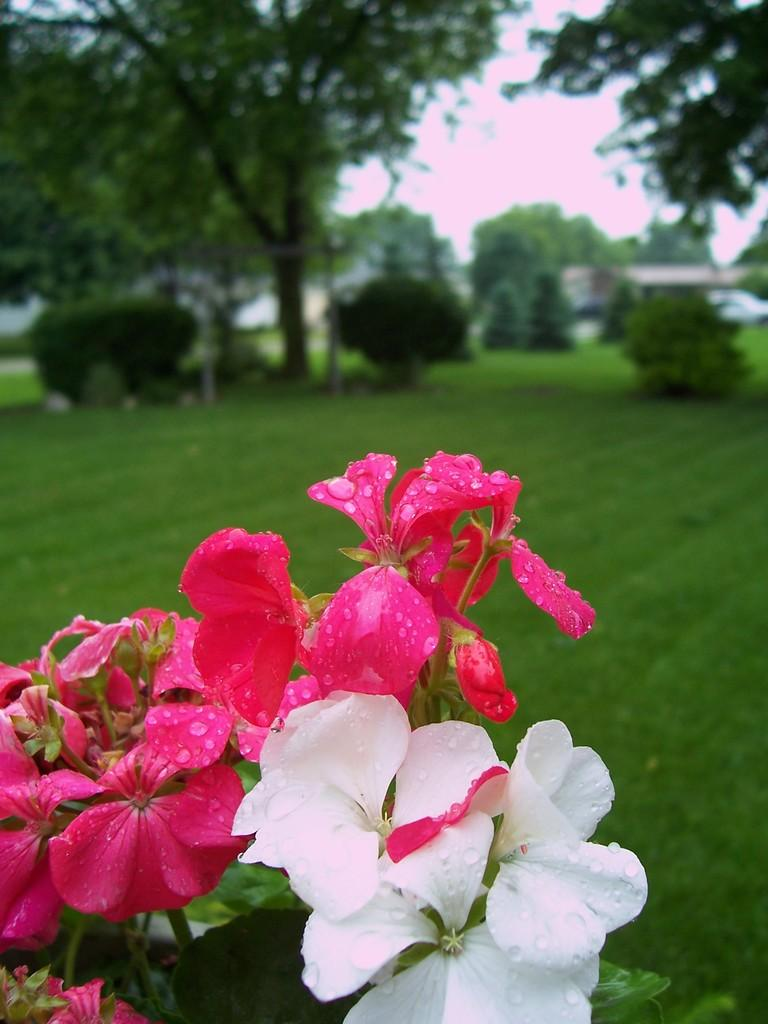What type of plants can be seen in the image? There are flowers, trees, and bushes in the image. What is the surface on which the plants are growing? There is grass on the surface in the image. What type of powder is visible on the leaves of the flowers in the image? There is no powder visible on the leaves of the flowers in the image. What color are the eyes of the trees in the image? Trees do not have eyes, so this question cannot be answered. 